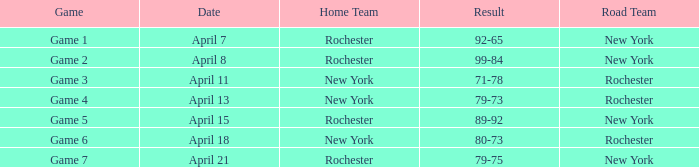Would you be able to parse every entry in this table? {'header': ['Game', 'Date', 'Home Team', 'Result', 'Road Team'], 'rows': [['Game 1', 'April 7', 'Rochester', '92-65', 'New York'], ['Game 2', 'April 8', 'Rochester', '99-84', 'New York'], ['Game 3', 'April 11', 'New York', '71-78', 'Rochester'], ['Game 4', 'April 13', 'New York', '79-73', 'Rochester'], ['Game 5', 'April 15', 'Rochester', '89-92', 'New York'], ['Game 6', 'April 18', 'New York', '80-73', 'Rochester'], ['Game 7', 'April 21', 'Rochester', '79-75', 'New York']]} Which Home Team has a Road Team of rochester, and a Result of 71-78? New York. 